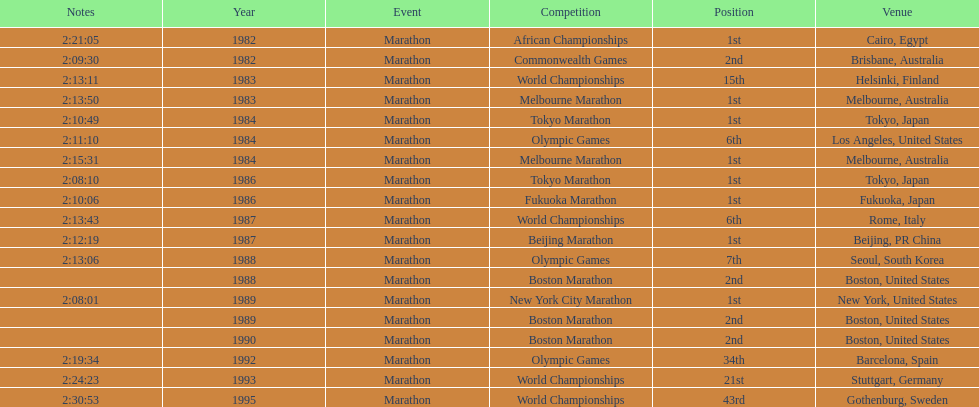What are the total number of times the position of 1st place was earned? 8. 